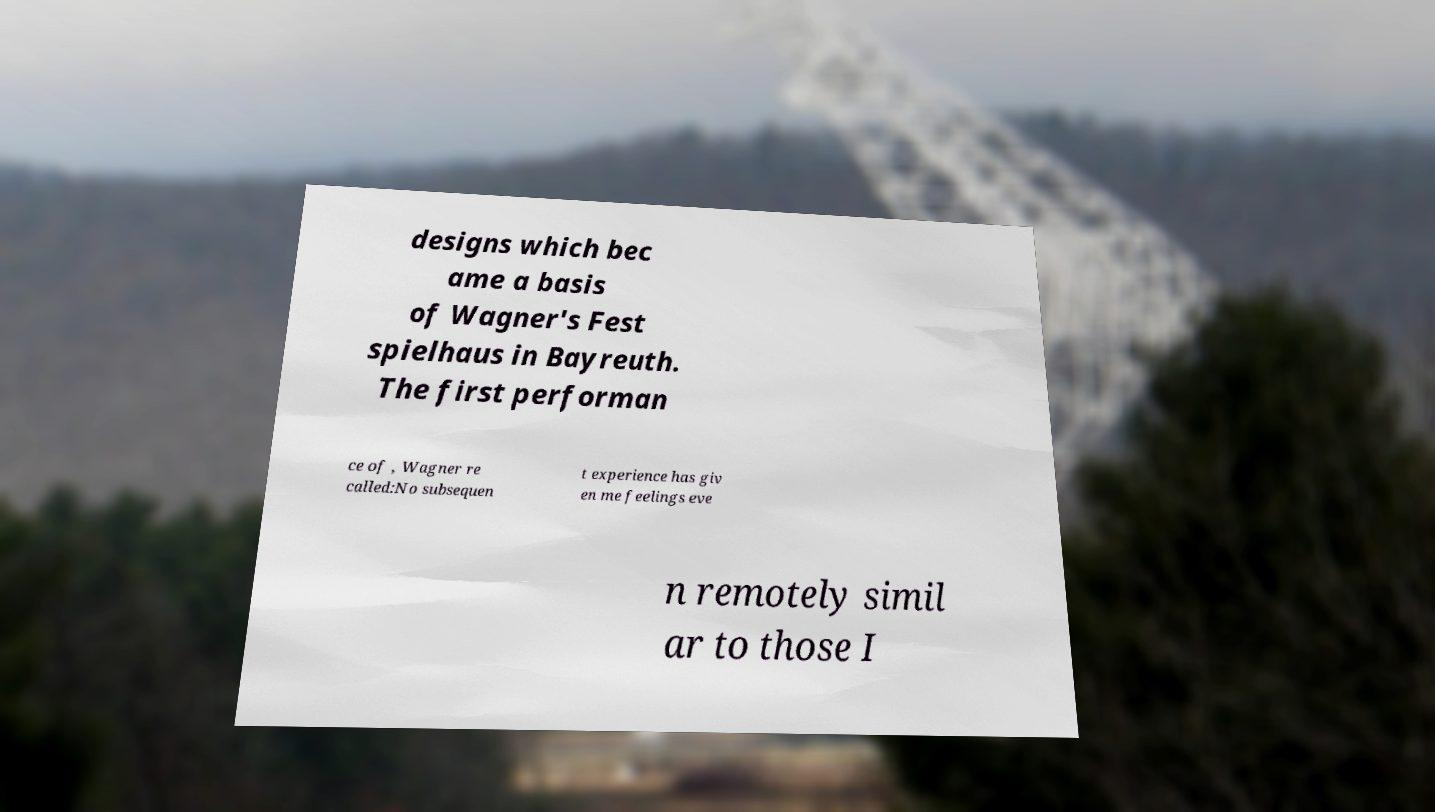Please read and relay the text visible in this image. What does it say? designs which bec ame a basis of Wagner's Fest spielhaus in Bayreuth. The first performan ce of , Wagner re called:No subsequen t experience has giv en me feelings eve n remotely simil ar to those I 